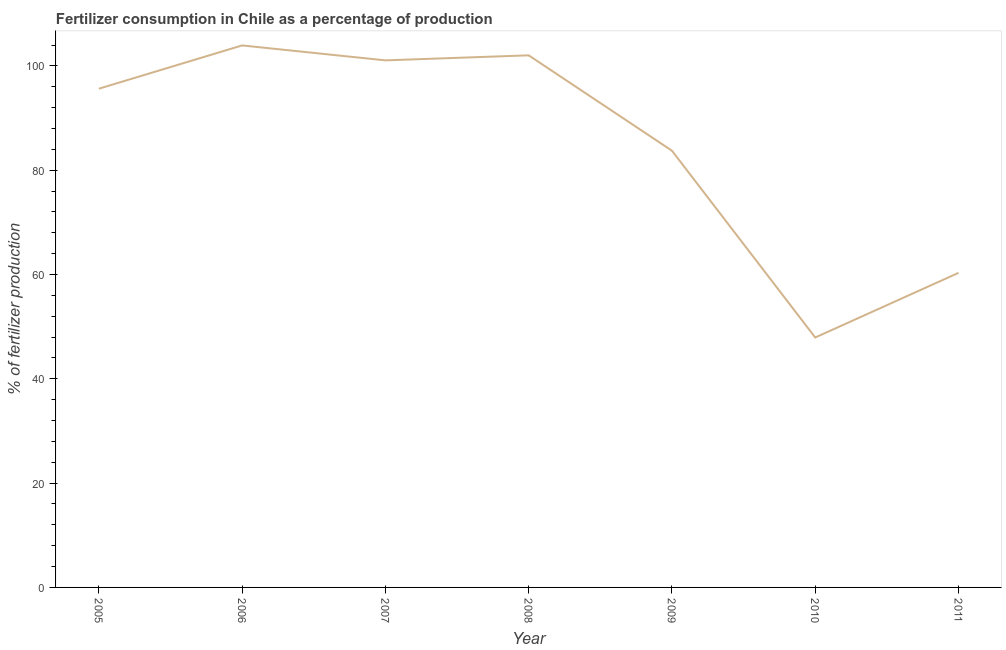What is the amount of fertilizer consumption in 2007?
Keep it short and to the point. 101.06. Across all years, what is the maximum amount of fertilizer consumption?
Provide a short and direct response. 103.92. Across all years, what is the minimum amount of fertilizer consumption?
Give a very brief answer. 47.92. In which year was the amount of fertilizer consumption minimum?
Your answer should be compact. 2010. What is the sum of the amount of fertilizer consumption?
Give a very brief answer. 594.58. What is the difference between the amount of fertilizer consumption in 2008 and 2011?
Offer a terse response. 41.71. What is the average amount of fertilizer consumption per year?
Keep it short and to the point. 84.94. What is the median amount of fertilizer consumption?
Provide a succinct answer. 95.62. In how many years, is the amount of fertilizer consumption greater than 40 %?
Your answer should be compact. 7. Do a majority of the years between 2011 and 2008 (inclusive) have amount of fertilizer consumption greater than 8 %?
Offer a terse response. Yes. What is the ratio of the amount of fertilizer consumption in 2008 to that in 2009?
Keep it short and to the point. 1.22. What is the difference between the highest and the second highest amount of fertilizer consumption?
Your answer should be compact. 1.9. What is the difference between the highest and the lowest amount of fertilizer consumption?
Keep it short and to the point. 56. Does the amount of fertilizer consumption monotonically increase over the years?
Make the answer very short. No. What is the difference between two consecutive major ticks on the Y-axis?
Offer a terse response. 20. Are the values on the major ticks of Y-axis written in scientific E-notation?
Make the answer very short. No. What is the title of the graph?
Ensure brevity in your answer.  Fertilizer consumption in Chile as a percentage of production. What is the label or title of the Y-axis?
Provide a succinct answer. % of fertilizer production. What is the % of fertilizer production of 2005?
Keep it short and to the point. 95.62. What is the % of fertilizer production of 2006?
Your answer should be compact. 103.92. What is the % of fertilizer production in 2007?
Provide a succinct answer. 101.06. What is the % of fertilizer production in 2008?
Keep it short and to the point. 102.02. What is the % of fertilizer production of 2009?
Offer a very short reply. 83.73. What is the % of fertilizer production in 2010?
Provide a succinct answer. 47.92. What is the % of fertilizer production in 2011?
Ensure brevity in your answer.  60.31. What is the difference between the % of fertilizer production in 2005 and 2006?
Make the answer very short. -8.3. What is the difference between the % of fertilizer production in 2005 and 2007?
Your response must be concise. -5.43. What is the difference between the % of fertilizer production in 2005 and 2008?
Provide a succinct answer. -6.4. What is the difference between the % of fertilizer production in 2005 and 2009?
Offer a terse response. 11.89. What is the difference between the % of fertilizer production in 2005 and 2010?
Offer a terse response. 47.7. What is the difference between the % of fertilizer production in 2005 and 2011?
Provide a short and direct response. 35.31. What is the difference between the % of fertilizer production in 2006 and 2007?
Your answer should be very brief. 2.86. What is the difference between the % of fertilizer production in 2006 and 2008?
Ensure brevity in your answer.  1.9. What is the difference between the % of fertilizer production in 2006 and 2009?
Offer a terse response. 20.19. What is the difference between the % of fertilizer production in 2006 and 2010?
Offer a terse response. 56. What is the difference between the % of fertilizer production in 2006 and 2011?
Provide a short and direct response. 43.61. What is the difference between the % of fertilizer production in 2007 and 2008?
Make the answer very short. -0.96. What is the difference between the % of fertilizer production in 2007 and 2009?
Offer a terse response. 17.32. What is the difference between the % of fertilizer production in 2007 and 2010?
Provide a succinct answer. 53.14. What is the difference between the % of fertilizer production in 2007 and 2011?
Ensure brevity in your answer.  40.74. What is the difference between the % of fertilizer production in 2008 and 2009?
Offer a very short reply. 18.29. What is the difference between the % of fertilizer production in 2008 and 2010?
Your answer should be very brief. 54.1. What is the difference between the % of fertilizer production in 2008 and 2011?
Your answer should be compact. 41.71. What is the difference between the % of fertilizer production in 2009 and 2010?
Your response must be concise. 35.81. What is the difference between the % of fertilizer production in 2009 and 2011?
Keep it short and to the point. 23.42. What is the difference between the % of fertilizer production in 2010 and 2011?
Your response must be concise. -12.39. What is the ratio of the % of fertilizer production in 2005 to that in 2007?
Your answer should be compact. 0.95. What is the ratio of the % of fertilizer production in 2005 to that in 2008?
Provide a short and direct response. 0.94. What is the ratio of the % of fertilizer production in 2005 to that in 2009?
Keep it short and to the point. 1.14. What is the ratio of the % of fertilizer production in 2005 to that in 2010?
Offer a very short reply. 2. What is the ratio of the % of fertilizer production in 2005 to that in 2011?
Provide a short and direct response. 1.58. What is the ratio of the % of fertilizer production in 2006 to that in 2007?
Offer a very short reply. 1.03. What is the ratio of the % of fertilizer production in 2006 to that in 2008?
Your answer should be very brief. 1.02. What is the ratio of the % of fertilizer production in 2006 to that in 2009?
Provide a short and direct response. 1.24. What is the ratio of the % of fertilizer production in 2006 to that in 2010?
Make the answer very short. 2.17. What is the ratio of the % of fertilizer production in 2006 to that in 2011?
Give a very brief answer. 1.72. What is the ratio of the % of fertilizer production in 2007 to that in 2009?
Your response must be concise. 1.21. What is the ratio of the % of fertilizer production in 2007 to that in 2010?
Provide a succinct answer. 2.11. What is the ratio of the % of fertilizer production in 2007 to that in 2011?
Your answer should be compact. 1.68. What is the ratio of the % of fertilizer production in 2008 to that in 2009?
Ensure brevity in your answer.  1.22. What is the ratio of the % of fertilizer production in 2008 to that in 2010?
Your answer should be very brief. 2.13. What is the ratio of the % of fertilizer production in 2008 to that in 2011?
Provide a short and direct response. 1.69. What is the ratio of the % of fertilizer production in 2009 to that in 2010?
Ensure brevity in your answer.  1.75. What is the ratio of the % of fertilizer production in 2009 to that in 2011?
Keep it short and to the point. 1.39. What is the ratio of the % of fertilizer production in 2010 to that in 2011?
Your answer should be very brief. 0.8. 